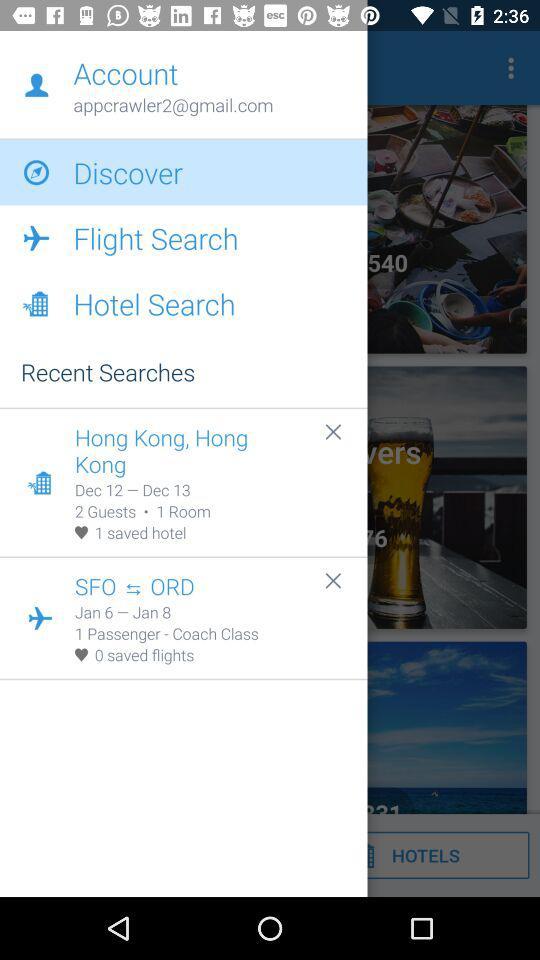How many passengers are there in coach class? There is 1 passenger. 